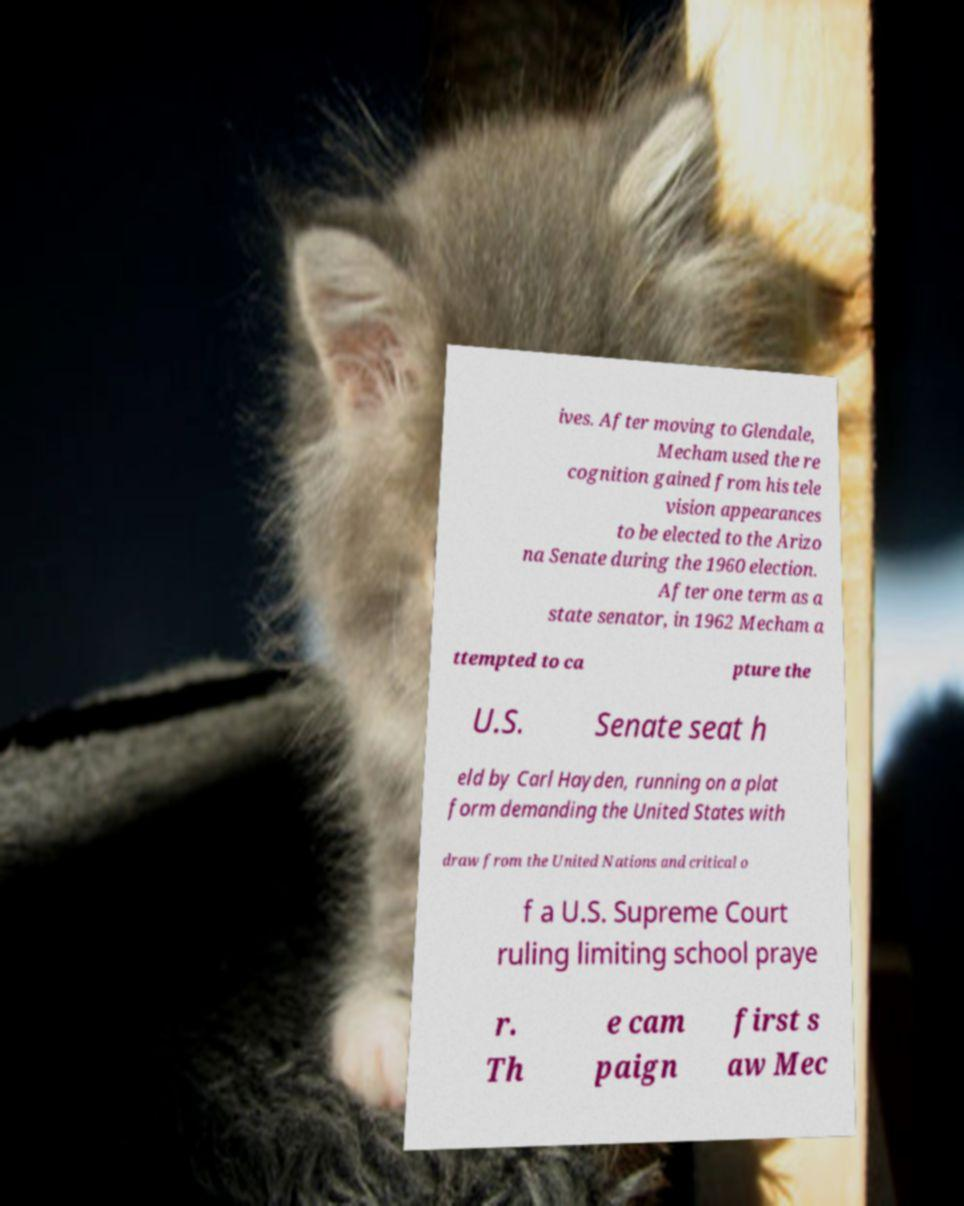Please read and relay the text visible in this image. What does it say? ives. After moving to Glendale, Mecham used the re cognition gained from his tele vision appearances to be elected to the Arizo na Senate during the 1960 election. After one term as a state senator, in 1962 Mecham a ttempted to ca pture the U.S. Senate seat h eld by Carl Hayden, running on a plat form demanding the United States with draw from the United Nations and critical o f a U.S. Supreme Court ruling limiting school praye r. Th e cam paign first s aw Mec 